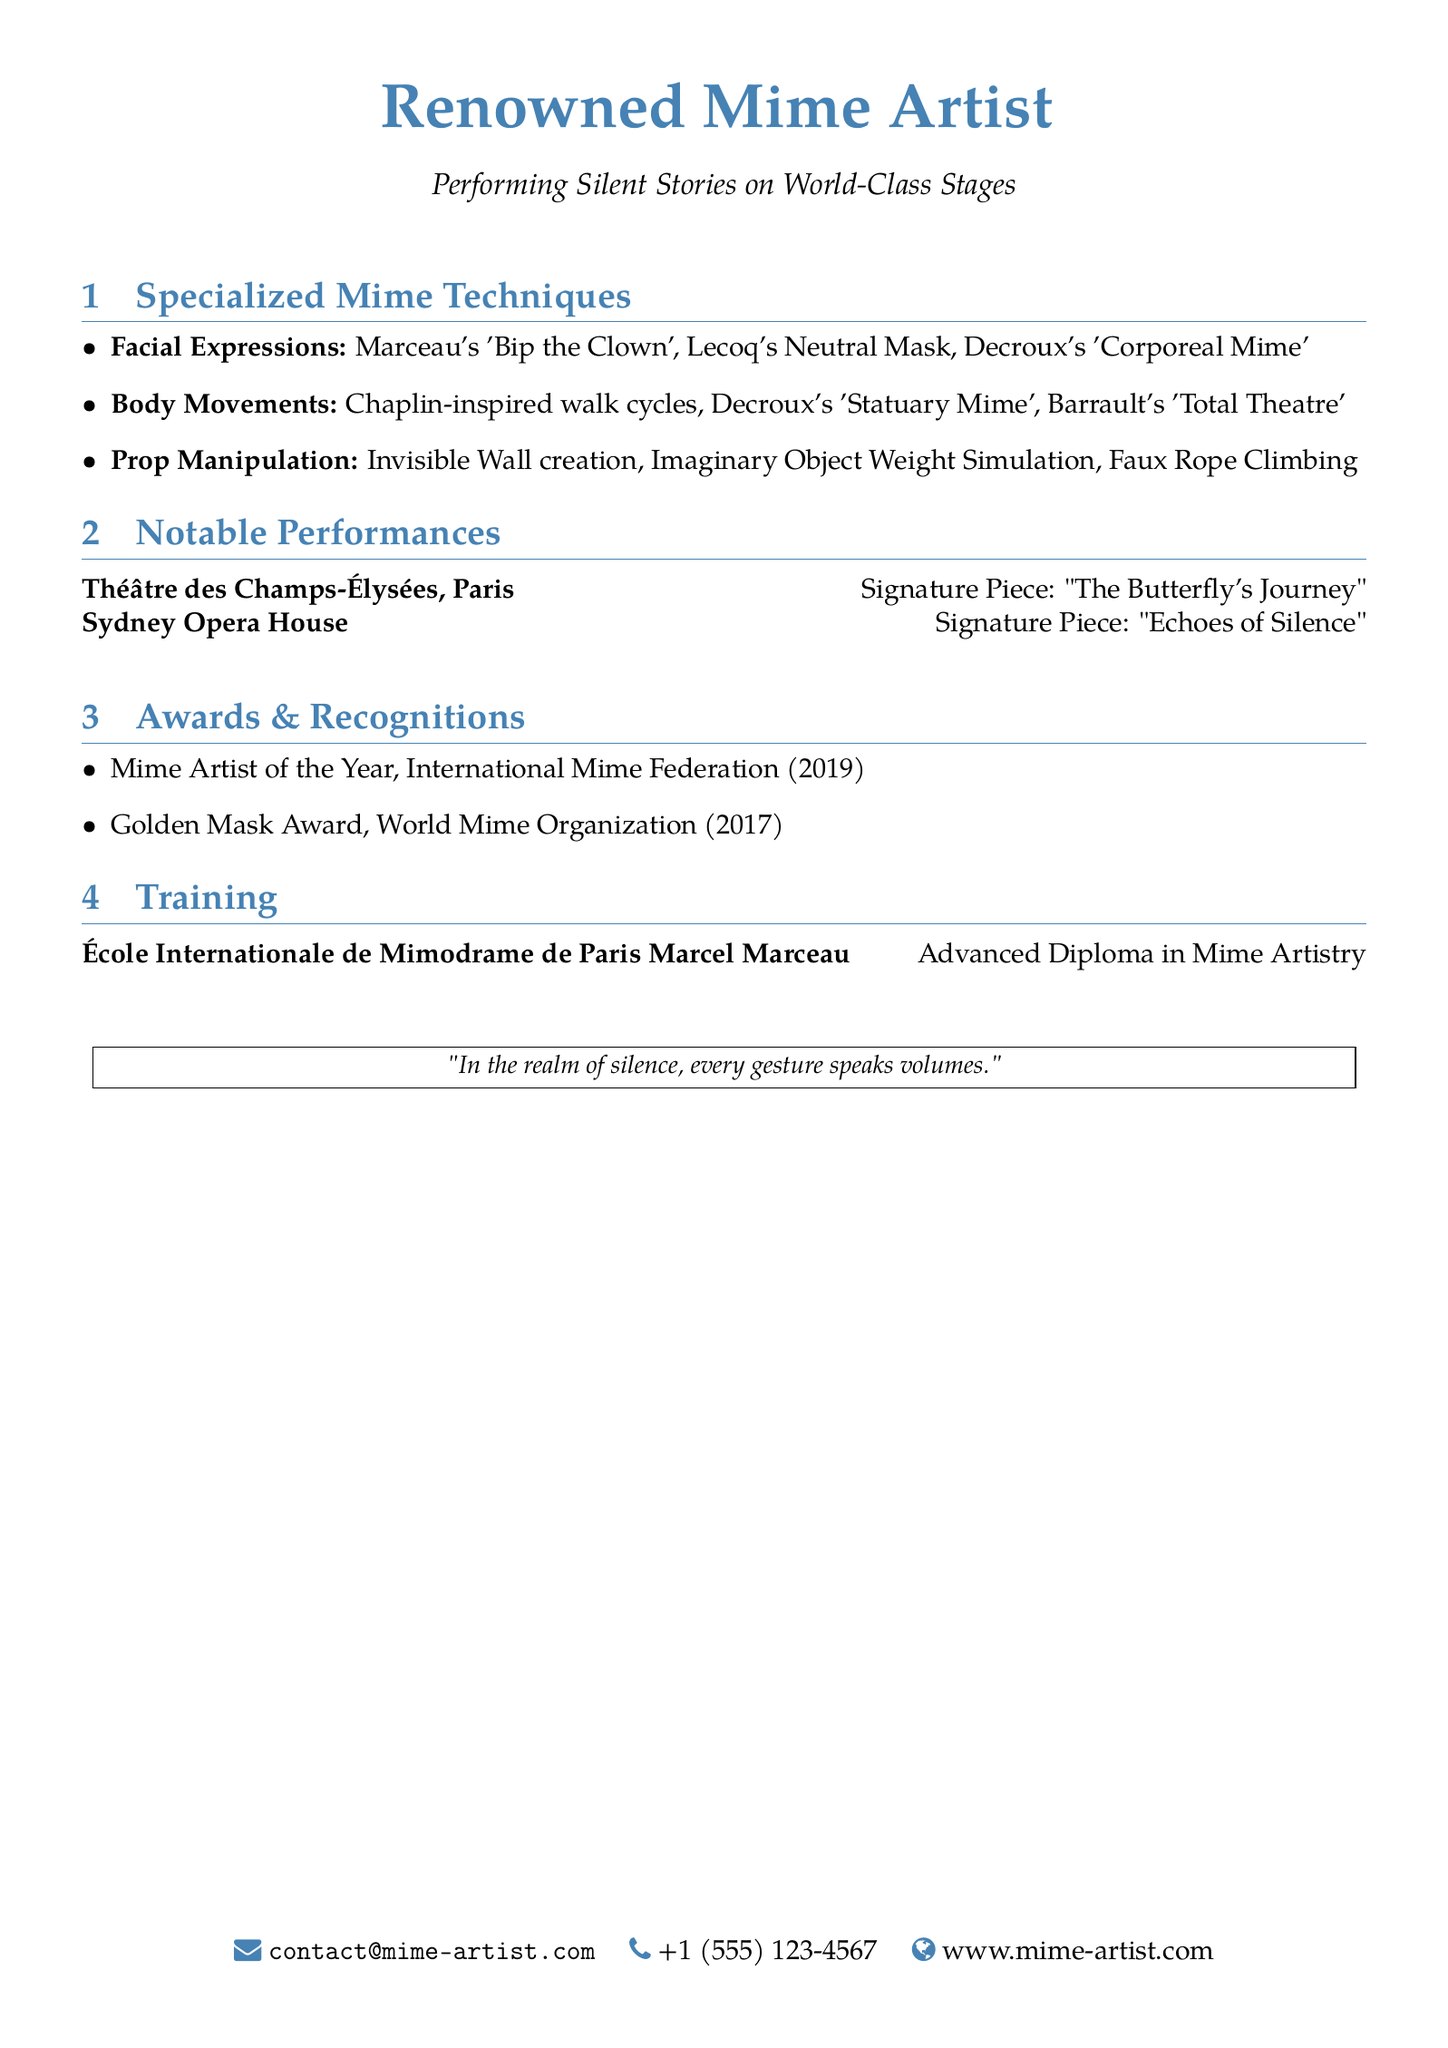What are the three categories of specialized mime techniques? The document lists Facial Expressions, Body Movements, and Prop Manipulation as the three specialized mime techniques.
Answer: Facial Expressions, Body Movements, Prop Manipulation Who is associated with the 'Bip the Clown' expressions? The technique 'Bip the Clown' is associated with mime artist Marceau.
Answer: Marceau What award did you win in 2019? The document states that the Mime Artist of the Year was awarded in 2019.
Answer: Mime Artist of the Year Which institution awarded the Advanced Diploma in Mime Artistry? The document specifies that the éDuplication is from École Internationale de Mimodrame de Paris Marcel Marceau.
Answer: École Internationale de Mimodrame de Paris Marcel Marceau What is the signature piece performed at Théâtre des Champs-Élysées? The signature piece mentioned for Théâtre des Champs-Élysées is "The Butterfly's Journey."
Answer: The Butterfly's Journey Name a technique from the Body Movements category. The document lists several techniques under Body Movements; for example, Chaplin-inspired walk cycles.
Answer: Chaplin-inspired walk cycles What is one technique used in Prop Manipulation? The document mentions Invisible Wall creation as a technique used in Prop Manipulation.
Answer: Invisible Wall creation How many awards are listed in the Awards & Recognitions section? The document lists a total of two awards.
Answer: 2 What is the theme of the quote included at the end of the document? The quote reflects on the expression of gestures in silence, emphasizing the theme of communication through mime.
Answer: Communication through mime 